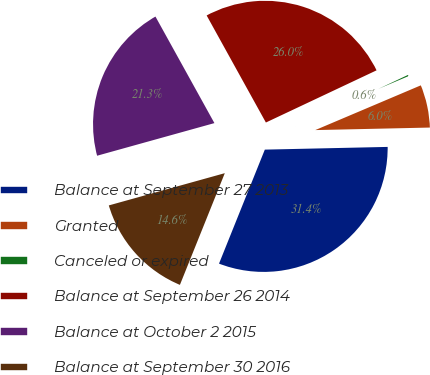Convert chart to OTSL. <chart><loc_0><loc_0><loc_500><loc_500><pie_chart><fcel>Balance at September 27 2013<fcel>Granted<fcel>Canceled or expired<fcel>Balance at September 26 2014<fcel>Balance at October 2 2015<fcel>Balance at September 30 2016<nl><fcel>31.43%<fcel>6.03%<fcel>0.63%<fcel>26.03%<fcel>21.27%<fcel>14.6%<nl></chart> 